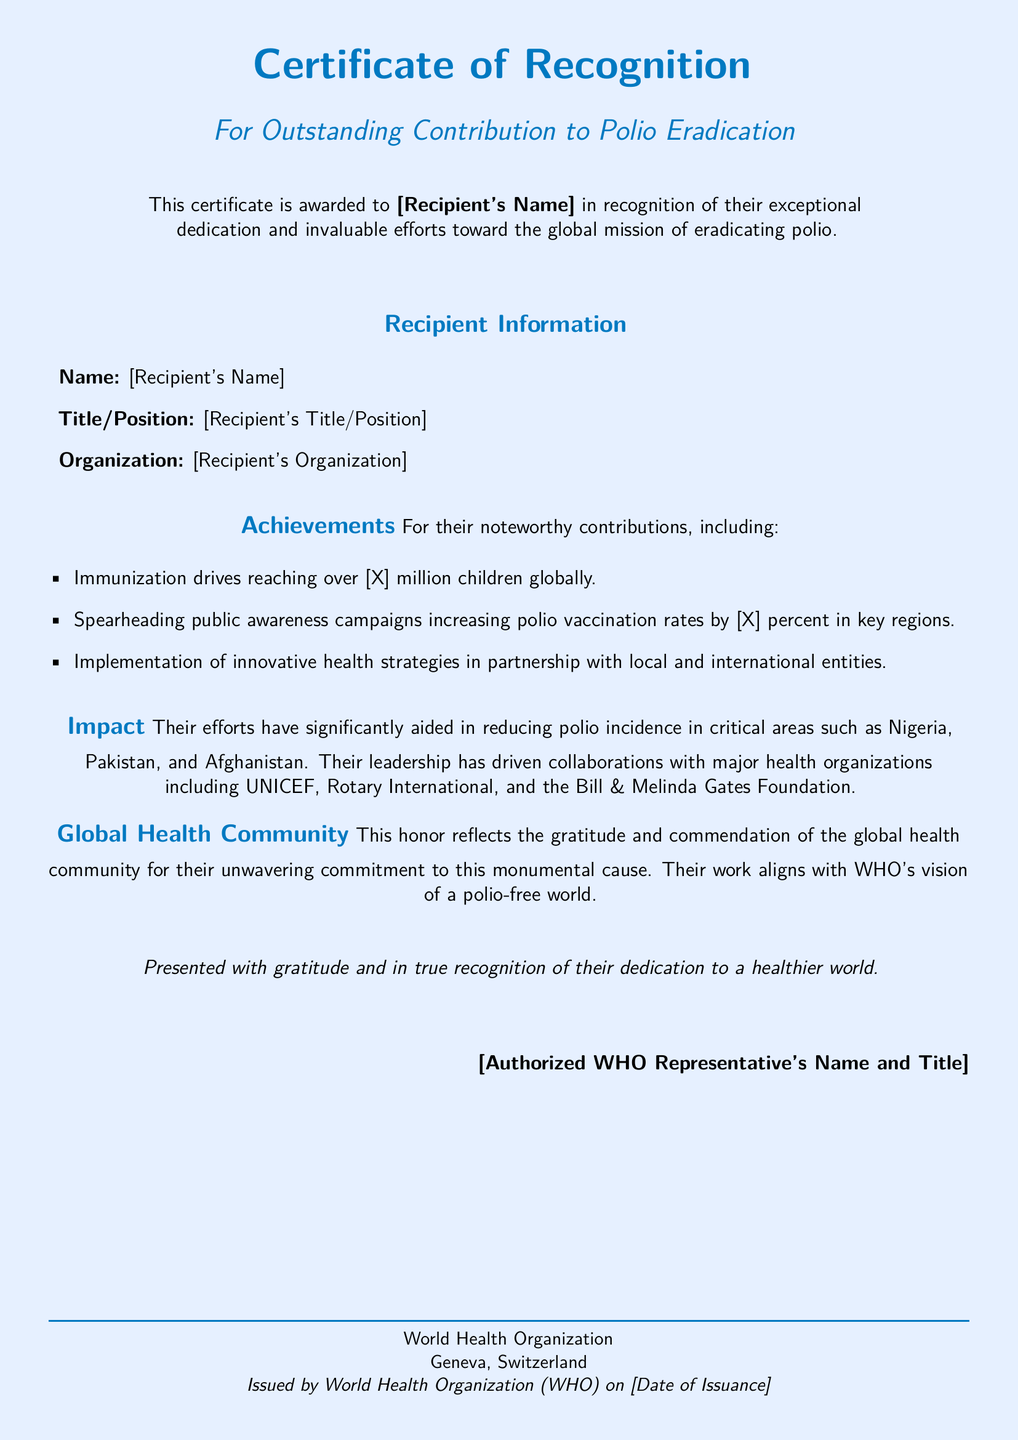What is the title of the certificate? The title is specifically mentioned at the top of the document as "Certificate of Recognition."
Answer: Certificate of Recognition Who is the recipient recognized for? The document states the recipient is recognized for "Outstanding Contribution to Polio Eradication."
Answer: Outstanding Contribution to Polio Eradication What is the organization of the recipient? The organization is indicated in the document as "[Recipient's Organization]."
Answer: [Recipient's Organization] How many children were reached during the immunization drives? The document mentions "over [X] million children globally" regarding immunization drives.
Answer: [X] million Which countries are highlighted for significant reduction in polio incidence? The text specifies Nigeria, Pakistan, and Afghanistan as critical areas.
Answer: Nigeria, Pakistan, Afghanistan Who presented the certificate? The document describes that the certificate is presented by "[Authorized WHO Representative's Name and Title]."
Answer: [Authorized WHO Representative's Name and Title] In which city is the World Health Organization located? The document states that the World Health Organization is located in Geneva, Switzerland.
Answer: Geneva What is one of the major health organizations mentioned in collaboration efforts? The document lists UNICEF as one of the major health organizations involved.
Answer: UNICEF What does the certificate reflect from the global health community? The certificate reflects "gratitude and commendation" from the global health community.
Answer: Gratitude and commendation 